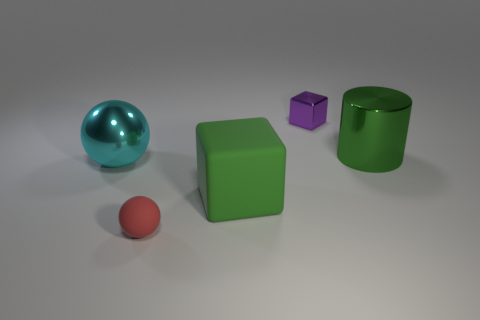Is there a green object that has the same size as the purple block?
Ensure brevity in your answer.  No. Does the small metal object have the same shape as the big rubber thing?
Provide a short and direct response. Yes. There is a tiny object that is behind the small thing in front of the tiny purple thing; is there a big shiny ball to the right of it?
Give a very brief answer. No. What number of other things are there of the same color as the metallic cylinder?
Keep it short and to the point. 1. Does the matte thing behind the tiny matte object have the same size as the matte thing left of the large matte thing?
Give a very brief answer. No. Are there an equal number of cubes in front of the green shiny object and large cubes that are in front of the big green rubber object?
Your answer should be compact. No. There is a green cylinder; does it have the same size as the block left of the metallic cube?
Offer a terse response. Yes. There is a big object that is left of the large green thing in front of the green shiny cylinder; what is its material?
Your answer should be very brief. Metal. Are there an equal number of cyan metal objects in front of the tiny rubber object and tiny purple cubes?
Your answer should be very brief. No. What size is the metallic object that is to the left of the large green metal cylinder and in front of the purple block?
Your answer should be compact. Large. 